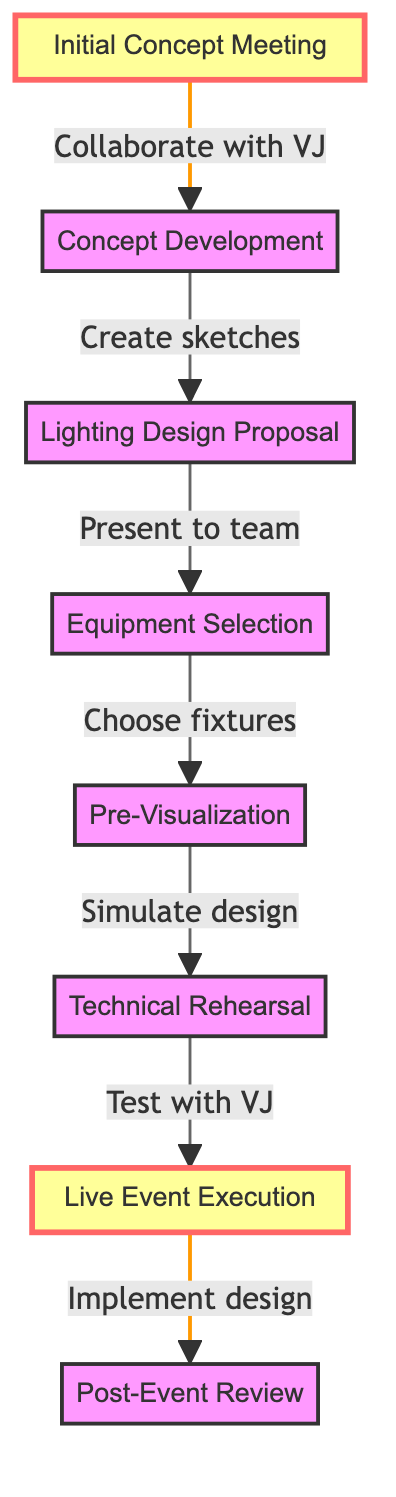What is the first step in the lighting design workflow? The diagram starts with the "Initial Concept Meeting" as the first node, indicating that this is where the process begins.
Answer: Initial Concept Meeting How many steps are there in the workflow? By counting each node in the diagram, we find there are a total of eight distinct steps from the initial concept meeting to the post-event review.
Answer: 8 Which step follows the "Lighting Design Proposal"? The diagram shows an arrow leading from "Lighting Design Proposal" directly to "Equipment Selection," indicating that this is the subsequent step.
Answer: Equipment Selection What is the last step in the lighting design workflow? The final step in the diagram is indicated as "Post-Event Review," which is the last node in the flowchart.
Answer: Post-Event Review During which stage do we test lighting with the VJ? According to the diagram, the stage where testing with the VJ occurs is labeled as "Technical Rehearsal."
Answer: Technical Rehearsal What activity occurs after "Pre-Visualization"? The flow from "Pre-Visualization" leads to "Technical Rehearsal," highlighting that this is the next activity to take place.
Answer: Technical Rehearsal Does the diagram indicate any feedback collection stage? Yes, the process includes a feedback stage named "Post-Event Review," which focuses on evaluating lighting effects after the event.
Answer: Post-Event Review What type of collaboration is highlighted in the initial step? The initial step emphasizes "Collaborate with VJ," indicating teamwork is crucial right from the beginning of the workflow.
Answer: Collaborate with VJ 